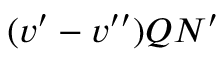<formula> <loc_0><loc_0><loc_500><loc_500>( v ^ { \prime } - v ^ { \prime \prime } ) Q N ^ { \prime }</formula> 